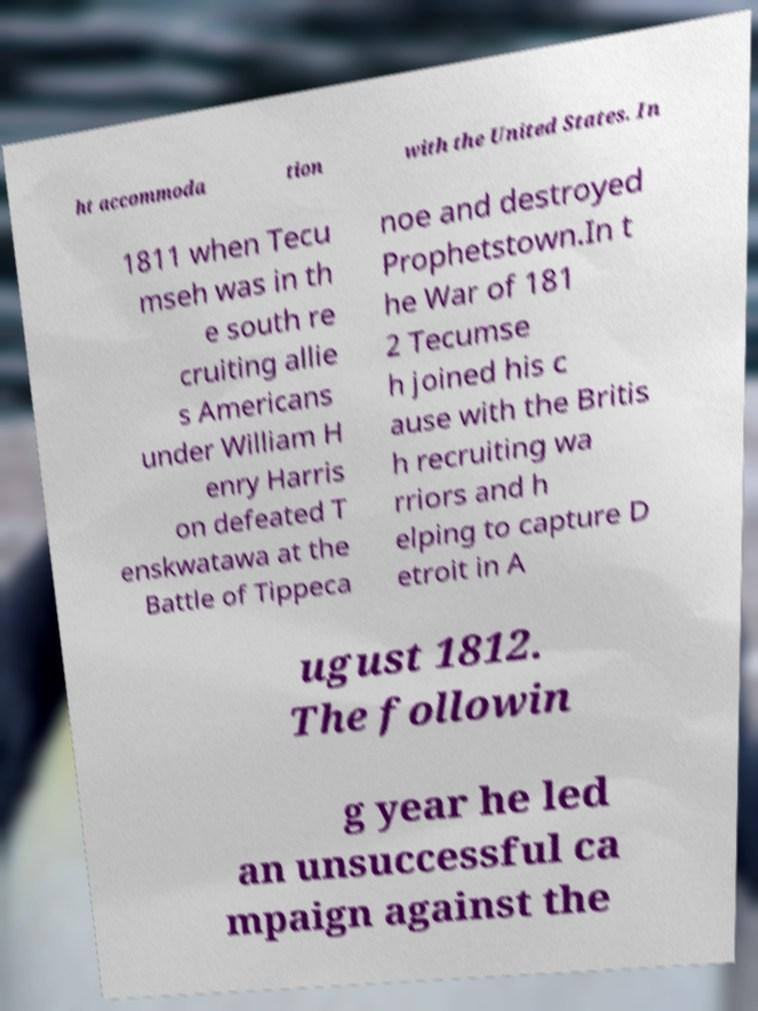What messages or text are displayed in this image? I need them in a readable, typed format. ht accommoda tion with the United States. In 1811 when Tecu mseh was in th e south re cruiting allie s Americans under William H enry Harris on defeated T enskwatawa at the Battle of Tippeca noe and destroyed Prophetstown.In t he War of 181 2 Tecumse h joined his c ause with the Britis h recruiting wa rriors and h elping to capture D etroit in A ugust 1812. The followin g year he led an unsuccessful ca mpaign against the 